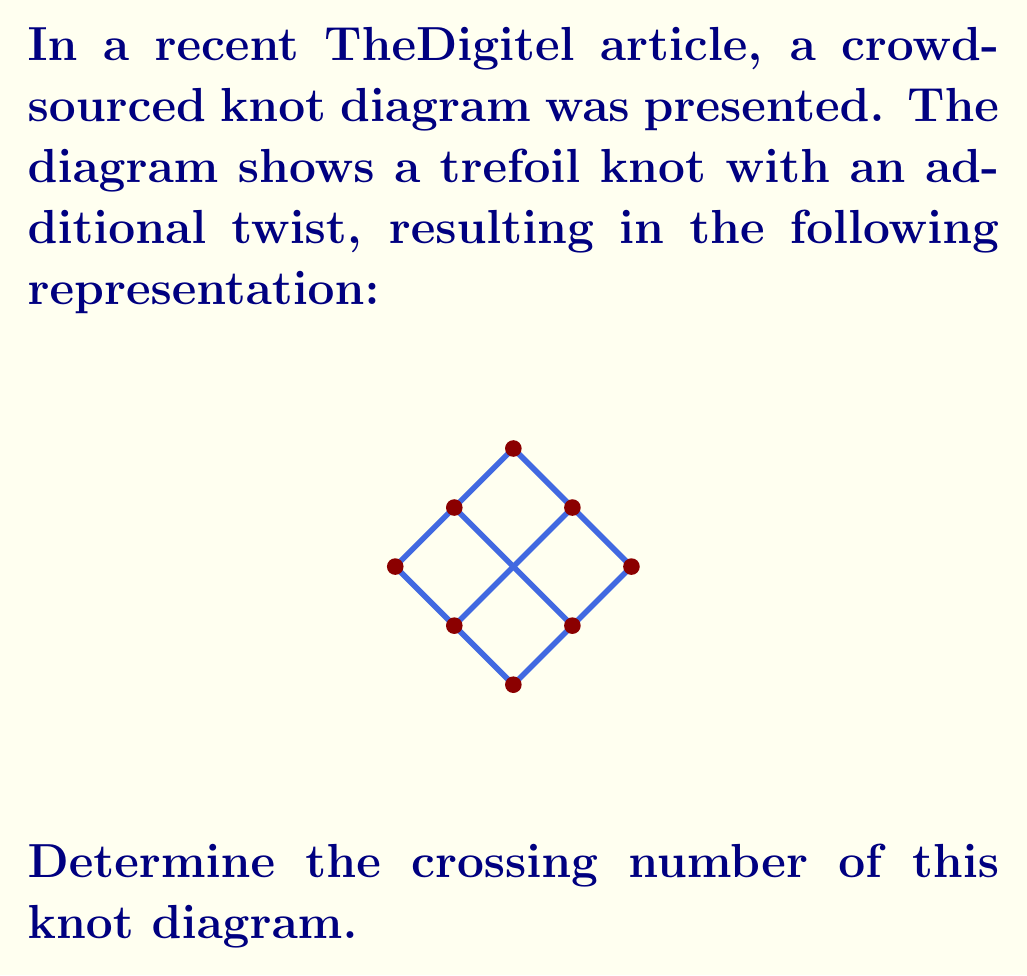Solve this math problem. To determine the crossing number of a knot diagram, we need to count the number of crossings in the diagram. Let's approach this step-by-step:

1. First, let's identify each crossing in the diagram:
   a. There are three crossings along the main trefoil shape.
   b. There is one additional crossing created by the extra twist in the middle.

2. Count the total number of crossings:
   $$ \text{Total crossings} = \text{Trefoil crossings} + \text{Additional twist crossing} $$
   $$ \text{Total crossings} = 3 + 1 = 4 $$

3. The crossing number of a knot diagram is defined as the minimum number of crossings over all possible diagrams of the knot. However, in this case, we are asked specifically about the crossing number of this given diagram, not the minimal crossing number of the knot it represents.

4. Therefore, the crossing number of this specific diagram is equal to the total number of crossings we counted.

It's worth noting that while this diagram has 4 crossings, the minimal crossing number for a trefoil knot is actually 3. The extra twist in this diagram adds a crossing without changing the underlying knot type.
Answer: 4 